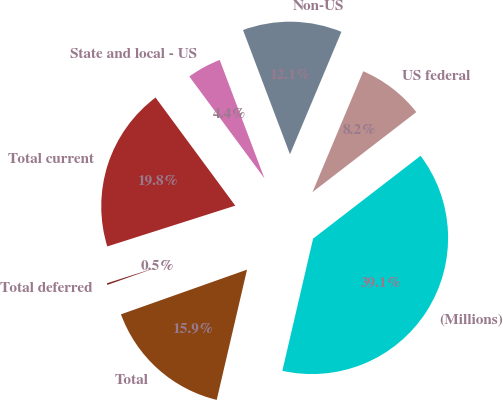Convert chart. <chart><loc_0><loc_0><loc_500><loc_500><pie_chart><fcel>(Millions)<fcel>US federal<fcel>Non-US<fcel>State and local - US<fcel>Total current<fcel>Total deferred<fcel>Total<nl><fcel>39.09%<fcel>8.22%<fcel>12.08%<fcel>4.36%<fcel>19.8%<fcel>0.51%<fcel>15.94%<nl></chart> 